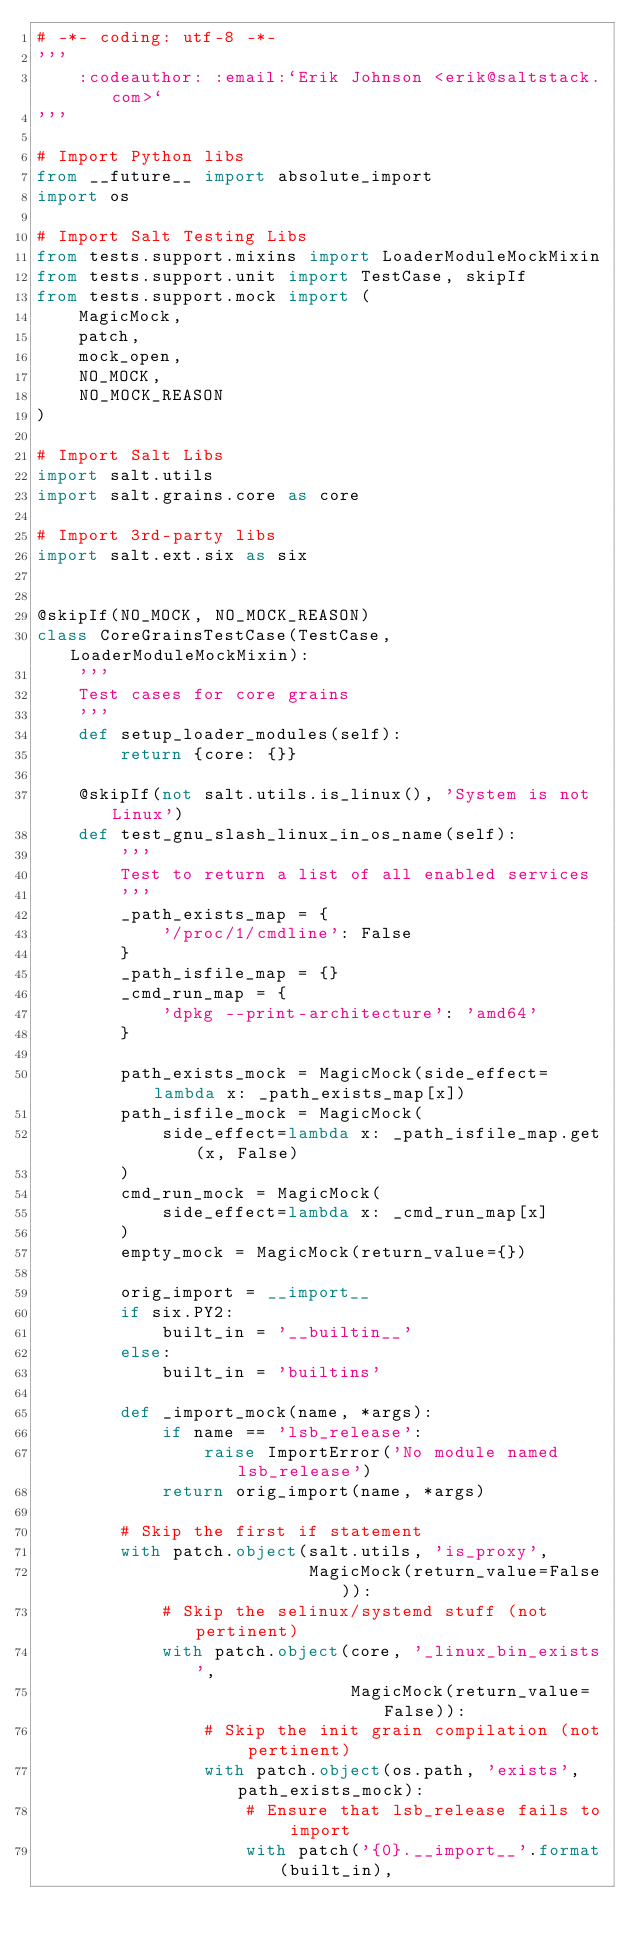<code> <loc_0><loc_0><loc_500><loc_500><_Python_># -*- coding: utf-8 -*-
'''
    :codeauthor: :email:`Erik Johnson <erik@saltstack.com>`
'''

# Import Python libs
from __future__ import absolute_import
import os

# Import Salt Testing Libs
from tests.support.mixins import LoaderModuleMockMixin
from tests.support.unit import TestCase, skipIf
from tests.support.mock import (
    MagicMock,
    patch,
    mock_open,
    NO_MOCK,
    NO_MOCK_REASON
)

# Import Salt Libs
import salt.utils
import salt.grains.core as core

# Import 3rd-party libs
import salt.ext.six as six


@skipIf(NO_MOCK, NO_MOCK_REASON)
class CoreGrainsTestCase(TestCase, LoaderModuleMockMixin):
    '''
    Test cases for core grains
    '''
    def setup_loader_modules(self):
        return {core: {}}

    @skipIf(not salt.utils.is_linux(), 'System is not Linux')
    def test_gnu_slash_linux_in_os_name(self):
        '''
        Test to return a list of all enabled services
        '''
        _path_exists_map = {
            '/proc/1/cmdline': False
        }
        _path_isfile_map = {}
        _cmd_run_map = {
            'dpkg --print-architecture': 'amd64'
        }

        path_exists_mock = MagicMock(side_effect=lambda x: _path_exists_map[x])
        path_isfile_mock = MagicMock(
            side_effect=lambda x: _path_isfile_map.get(x, False)
        )
        cmd_run_mock = MagicMock(
            side_effect=lambda x: _cmd_run_map[x]
        )
        empty_mock = MagicMock(return_value={})

        orig_import = __import__
        if six.PY2:
            built_in = '__builtin__'
        else:
            built_in = 'builtins'

        def _import_mock(name, *args):
            if name == 'lsb_release':
                raise ImportError('No module named lsb_release')
            return orig_import(name, *args)

        # Skip the first if statement
        with patch.object(salt.utils, 'is_proxy',
                          MagicMock(return_value=False)):
            # Skip the selinux/systemd stuff (not pertinent)
            with patch.object(core, '_linux_bin_exists',
                              MagicMock(return_value=False)):
                # Skip the init grain compilation (not pertinent)
                with patch.object(os.path, 'exists', path_exists_mock):
                    # Ensure that lsb_release fails to import
                    with patch('{0}.__import__'.format(built_in),</code> 